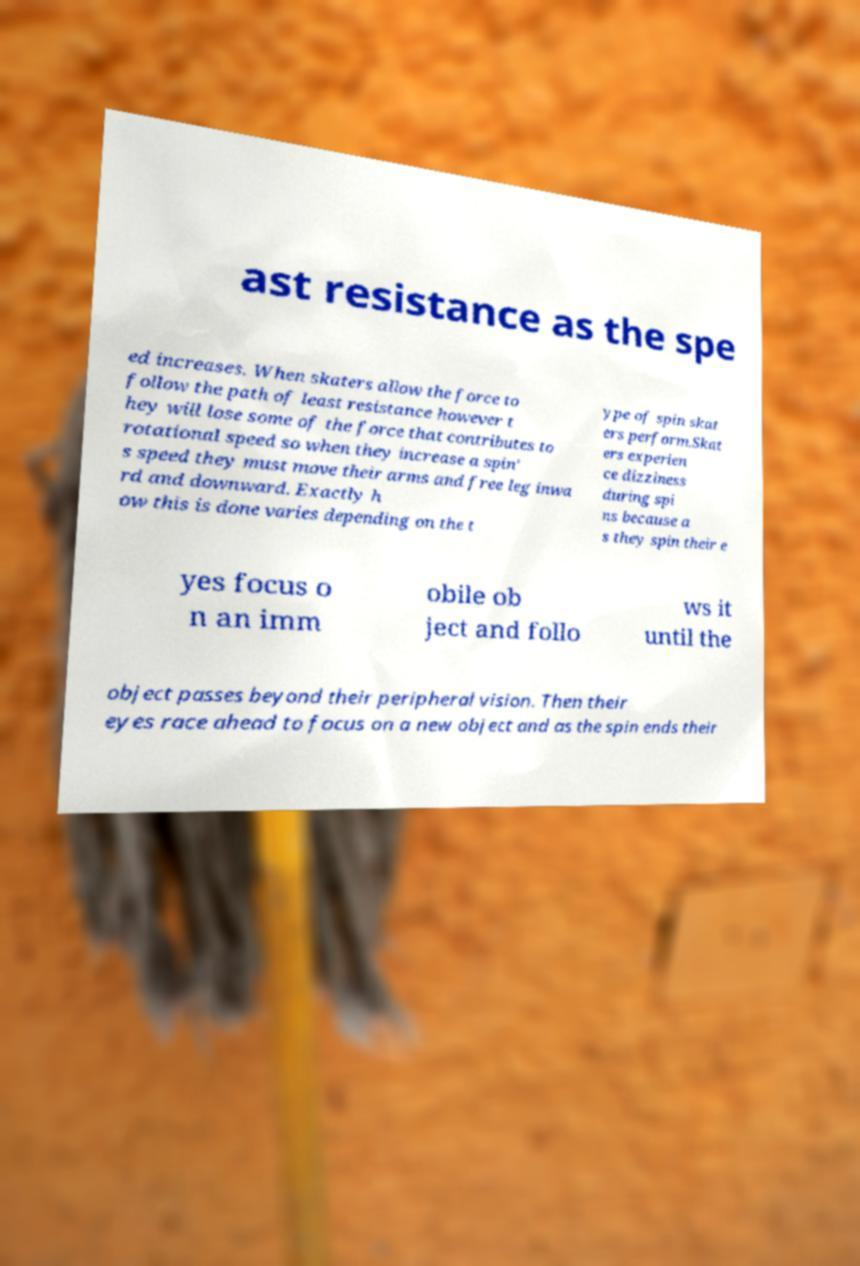What messages or text are displayed in this image? I need them in a readable, typed format. ast resistance as the spe ed increases. When skaters allow the force to follow the path of least resistance however t hey will lose some of the force that contributes to rotational speed so when they increase a spin' s speed they must move their arms and free leg inwa rd and downward. Exactly h ow this is done varies depending on the t ype of spin skat ers perform.Skat ers experien ce dizziness during spi ns because a s they spin their e yes focus o n an imm obile ob ject and follo ws it until the object passes beyond their peripheral vision. Then their eyes race ahead to focus on a new object and as the spin ends their 